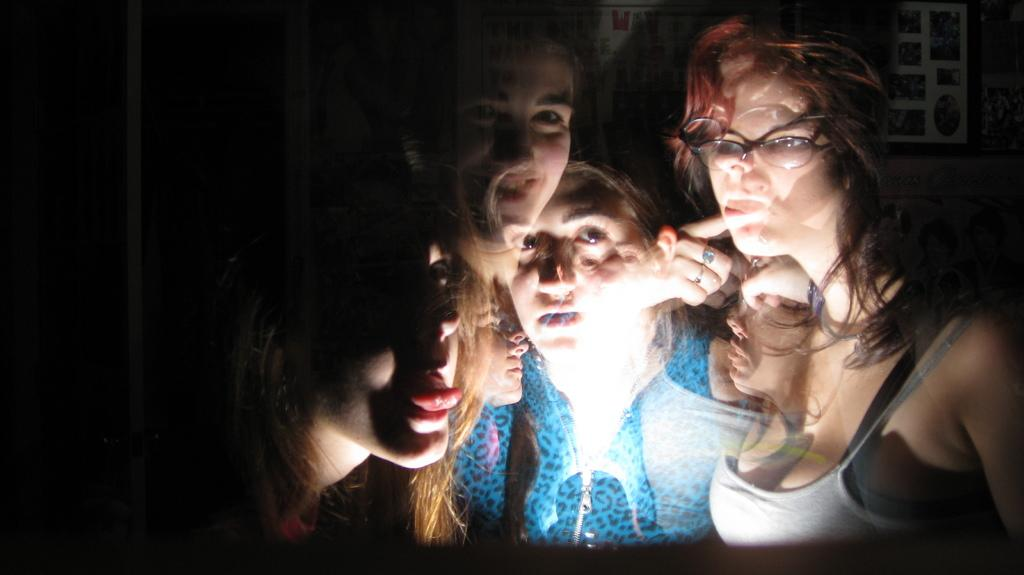What is the nature of the image? The image is a reflection in a mirror or glass. Who or what can be seen in the image? There are women in the image. Is there any source of light visible in the image? Yes, there is a light in the image. How would you describe the lighting on the left side of the image? The left side of the image is dark. What action are the women performing in the image? The provided facts do not mention any specific actions being performed by the women in the image. --- 